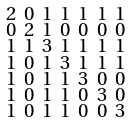Convert formula to latex. <formula><loc_0><loc_0><loc_500><loc_500>\begin{smallmatrix} 2 & 0 & 1 & 1 & 1 & 1 & 1 \\ 0 & 2 & 1 & 0 & 0 & 0 & 0 \\ 1 & 1 & 3 & 1 & 1 & 1 & 1 \\ 1 & 0 & 1 & 3 & 1 & 1 & 1 \\ 1 & 0 & 1 & 1 & 3 & 0 & 0 \\ 1 & 0 & 1 & 1 & 0 & 3 & 0 \\ 1 & 0 & 1 & 1 & 0 & 0 & 3 \end{smallmatrix}</formula> 